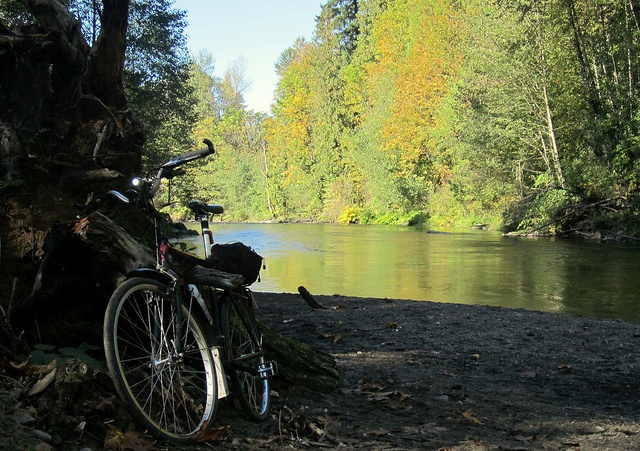Describe the objects in this image and their specific colors. I can see bicycle in olive, black, gray, darkgreen, and darkgray tones and backpack in olive, black, lightblue, and darkgray tones in this image. 